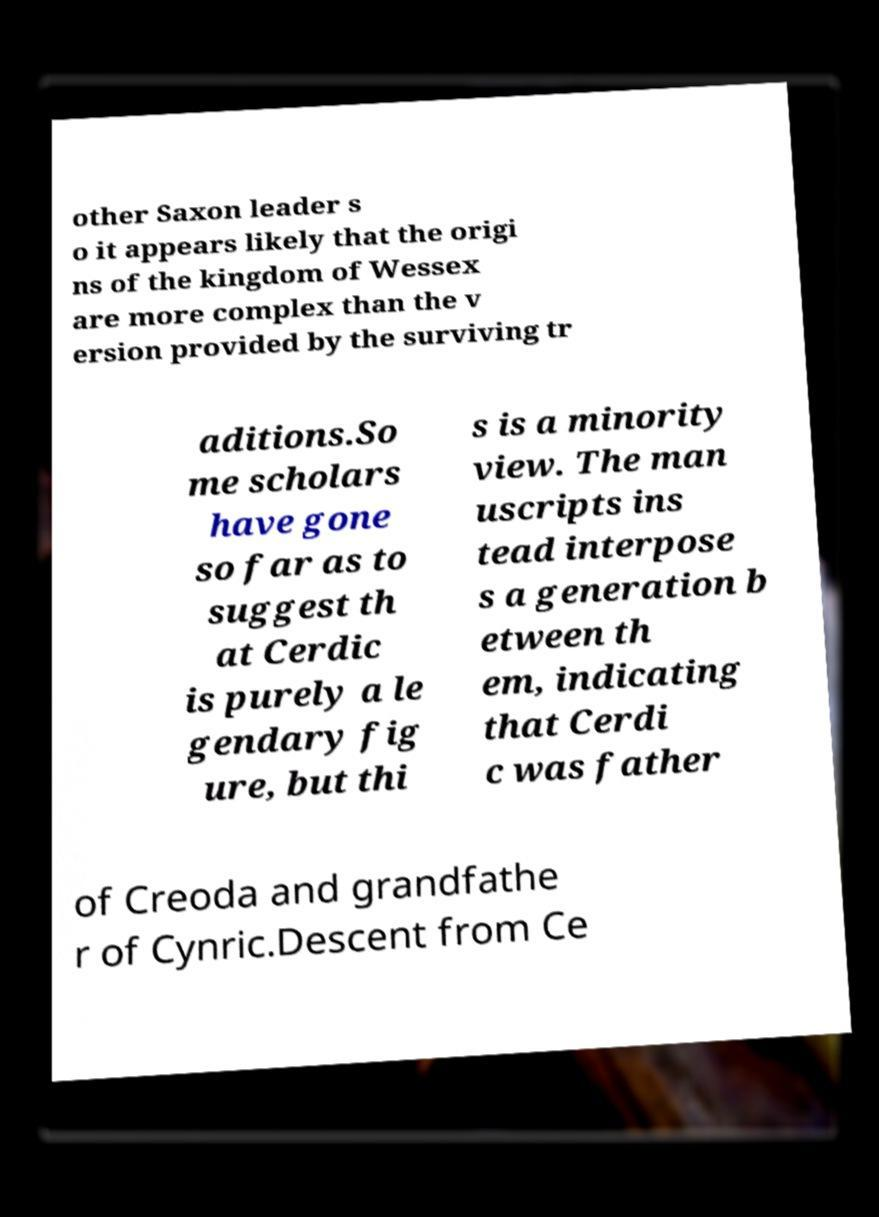Can you read and provide the text displayed in the image?This photo seems to have some interesting text. Can you extract and type it out for me? other Saxon leader s o it appears likely that the origi ns of the kingdom of Wessex are more complex than the v ersion provided by the surviving tr aditions.So me scholars have gone so far as to suggest th at Cerdic is purely a le gendary fig ure, but thi s is a minority view. The man uscripts ins tead interpose s a generation b etween th em, indicating that Cerdi c was father of Creoda and grandfathe r of Cynric.Descent from Ce 